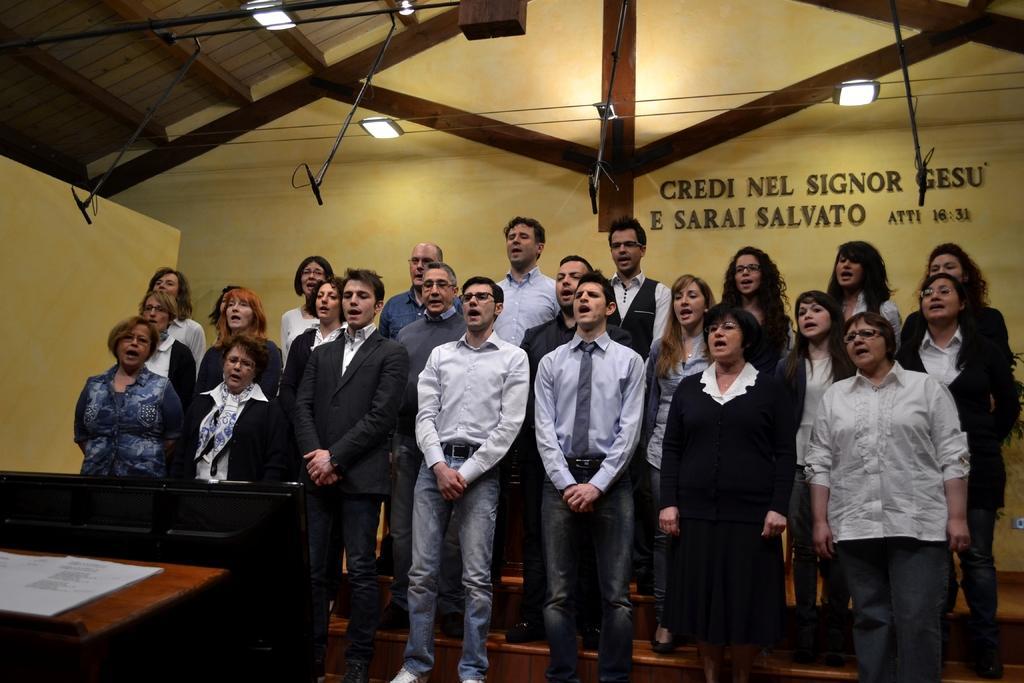Describe this image in one or two sentences. In this image we can see men and women standing on the stairs. In addition to this there are electric lights, some text on the wall and a book on the table. 